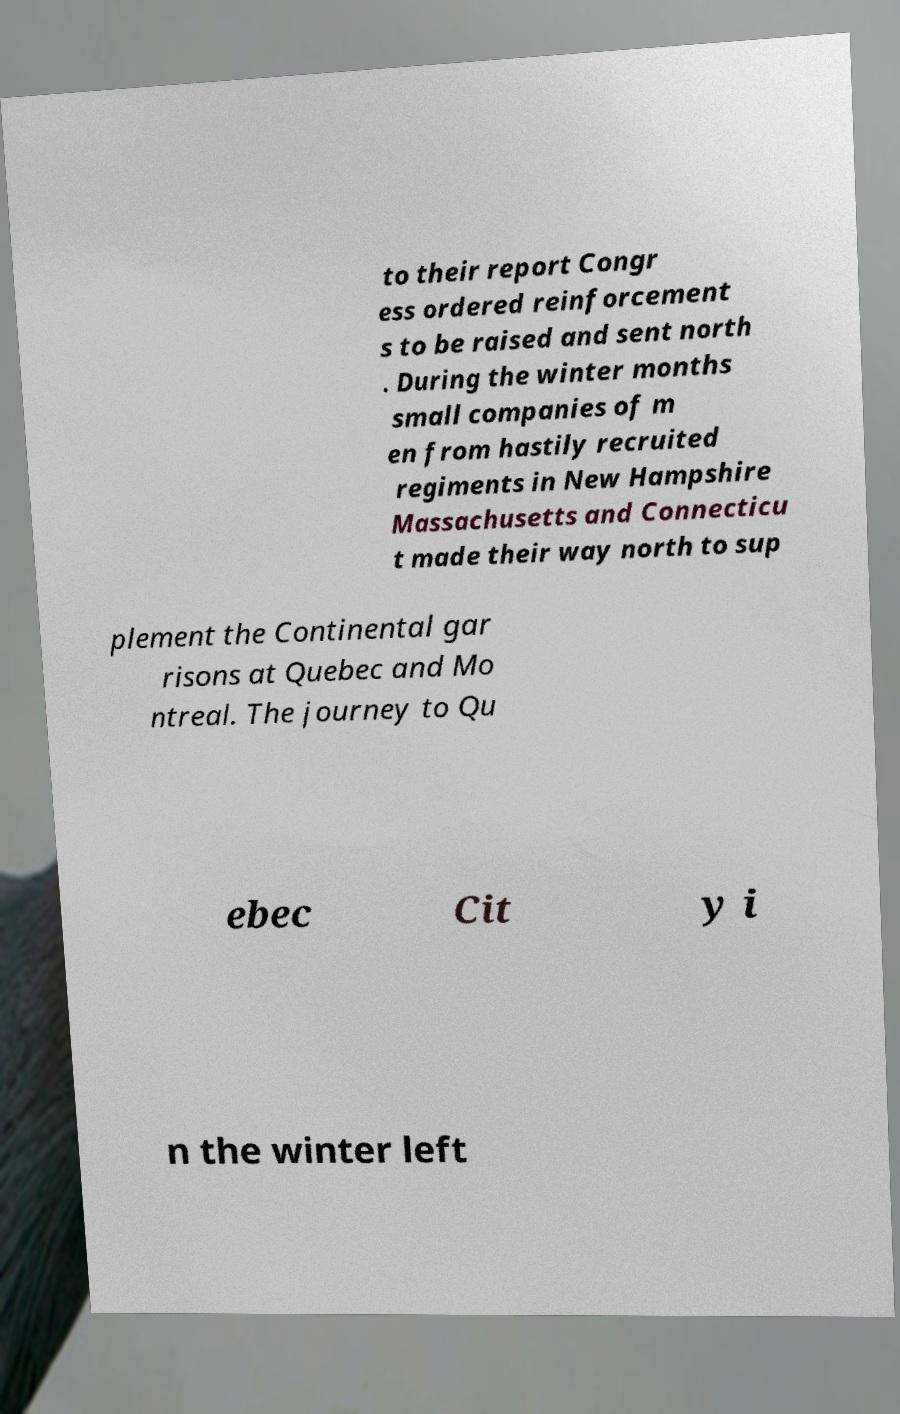For documentation purposes, I need the text within this image transcribed. Could you provide that? to their report Congr ess ordered reinforcement s to be raised and sent north . During the winter months small companies of m en from hastily recruited regiments in New Hampshire Massachusetts and Connecticu t made their way north to sup plement the Continental gar risons at Quebec and Mo ntreal. The journey to Qu ebec Cit y i n the winter left 